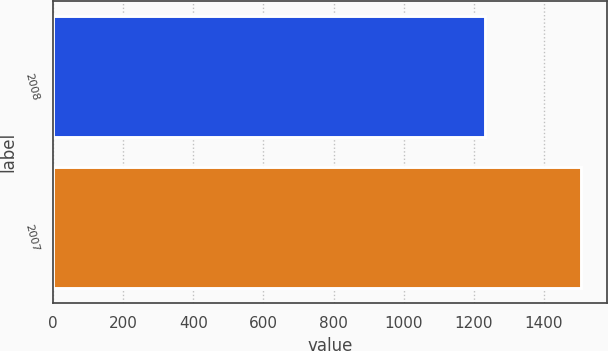<chart> <loc_0><loc_0><loc_500><loc_500><bar_chart><fcel>2008<fcel>2007<nl><fcel>1232<fcel>1505<nl></chart> 